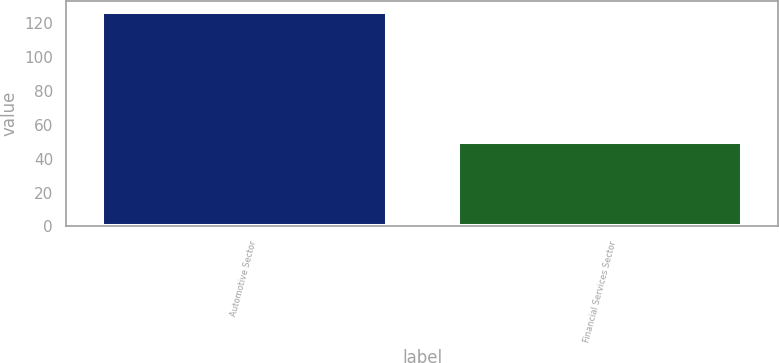Convert chart to OTSL. <chart><loc_0><loc_0><loc_500><loc_500><bar_chart><fcel>Automotive Sector<fcel>Financial Services Sector<nl><fcel>127<fcel>50<nl></chart> 